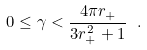<formula> <loc_0><loc_0><loc_500><loc_500>0 \leq \gamma < \frac { 4 \pi r _ { + } } { 3 r _ { + } ^ { 2 } + 1 } \ .</formula> 